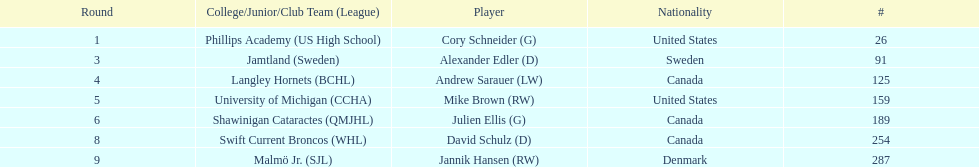The first round not to have a draft pick. 2. 